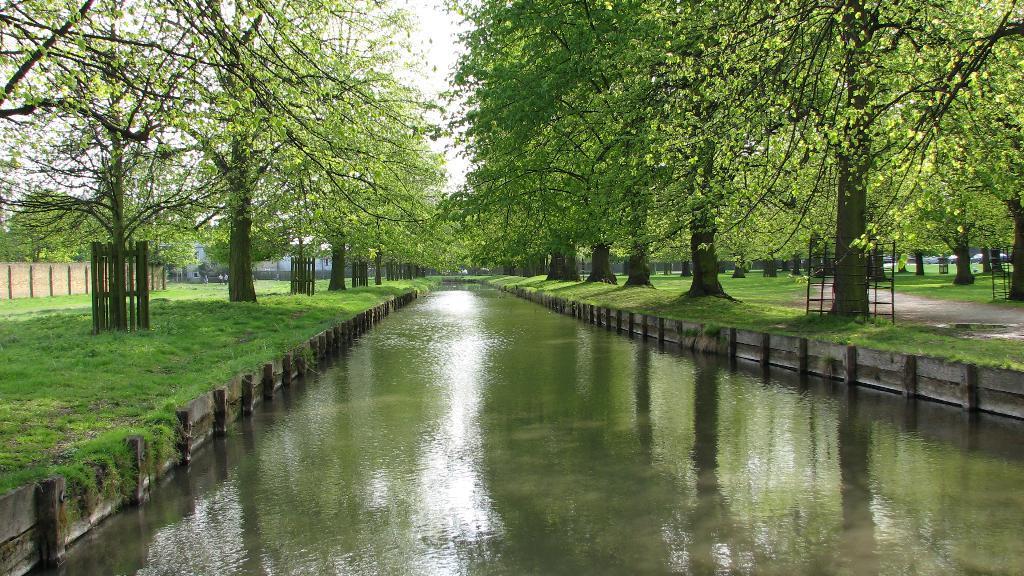Can you describe this image briefly? This picture shows few trees and we see water and grass on the ground and a wall and we see few people standing and we see fence around few trees and a cloudy Sky. 